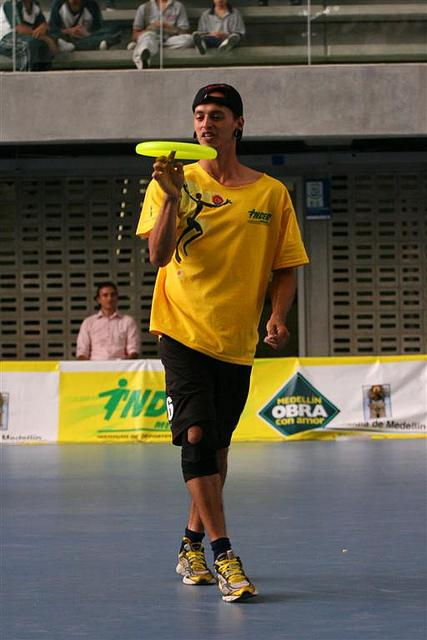The dominant color on the shirt is the same color as what food item? banana 